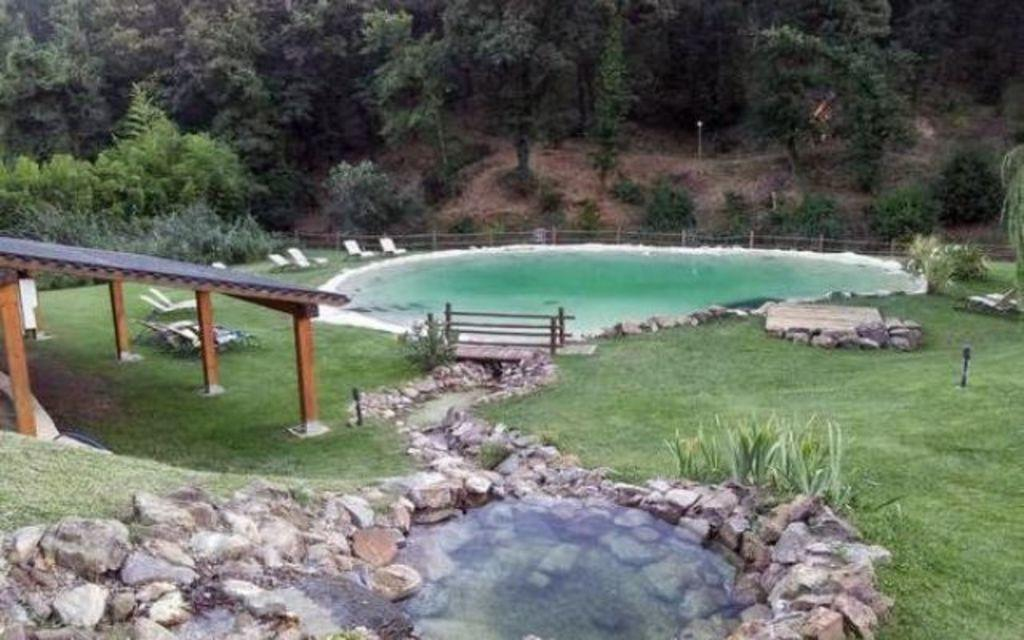What is the main feature in the middle of the image? There is a swimming pool in the middle of the image. What can be found near the swimming pool? There are benches beside the swimming pool. What other body of water is present in the image? There is a pond in the image. What type of structure can be seen in the image? There is a shed in the image. What type of vegetation is present in the image? There are trees in the image. What type of game is being played on the cloud in the image? There is no cloud or game present in the image. What color are the bricks used to build the shed in the image? The provided facts do not mention the color or material of the shed, so we cannot determine the color of the bricks. 